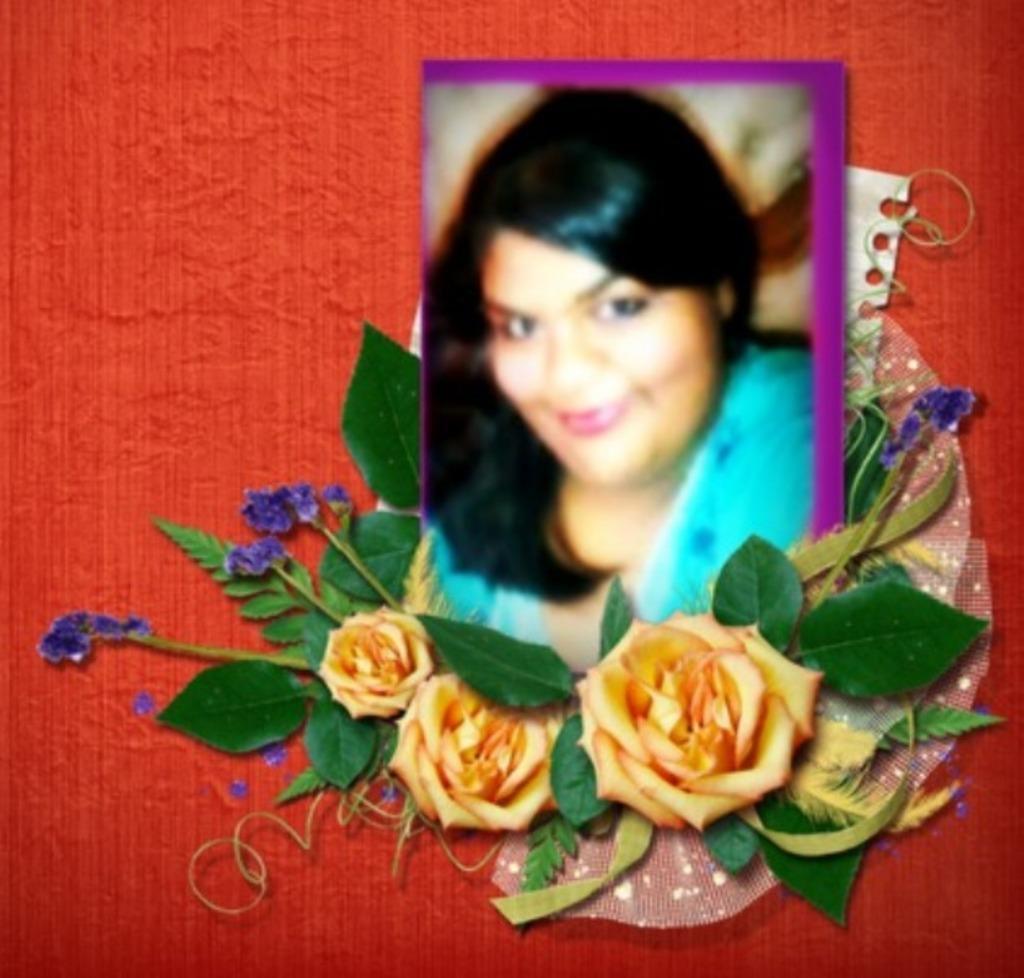Can you describe this image briefly? In this image we can see a blurred picture of a woman wearing blue dress is smiling. Here we can see yellow color flowers and a paper here. The background of the image is red in color. 